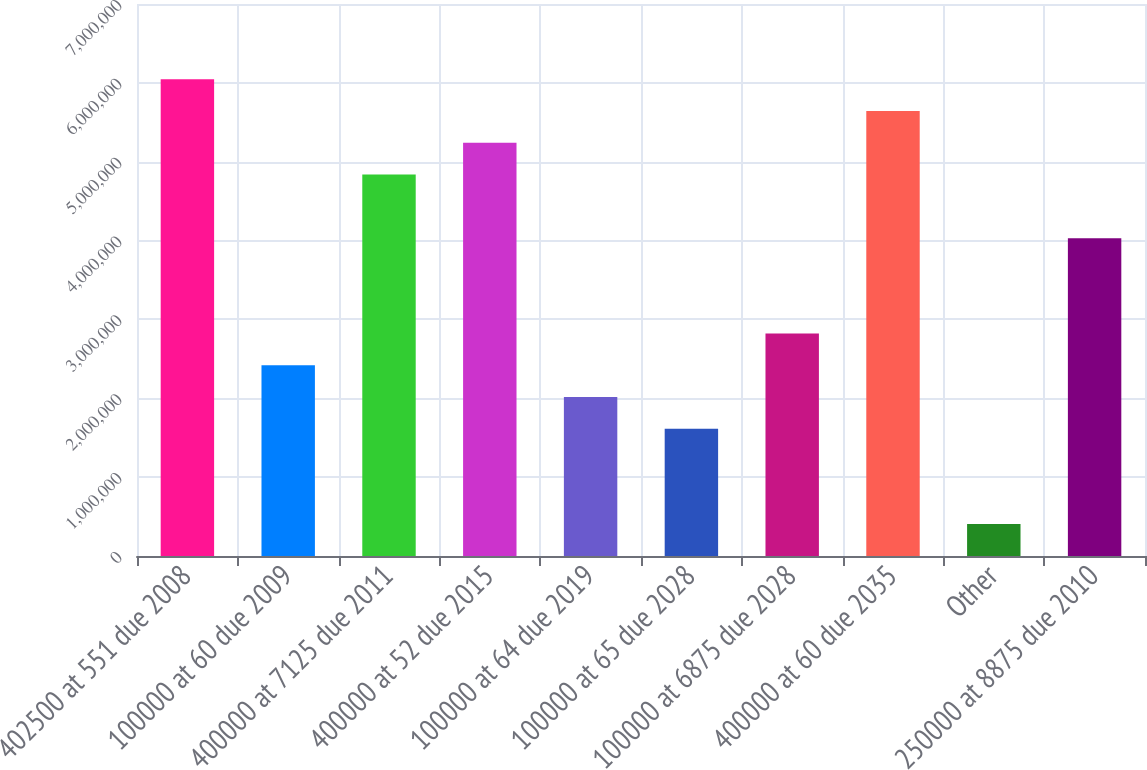Convert chart. <chart><loc_0><loc_0><loc_500><loc_500><bar_chart><fcel>402500 at 551 due 2008<fcel>100000 at 60 due 2009<fcel>400000 at 7125 due 2011<fcel>400000 at 52 due 2015<fcel>100000 at 64 due 2019<fcel>100000 at 65 due 2028<fcel>100000 at 6875 due 2028<fcel>400000 at 60 due 2035<fcel>Other<fcel>250000 at 8875 due 2010<nl><fcel>6.04478e+06<fcel>2.41971e+06<fcel>4.83643e+06<fcel>5.23921e+06<fcel>2.01693e+06<fcel>1.61414e+06<fcel>2.8225e+06<fcel>5.642e+06<fcel>405783<fcel>4.03086e+06<nl></chart> 